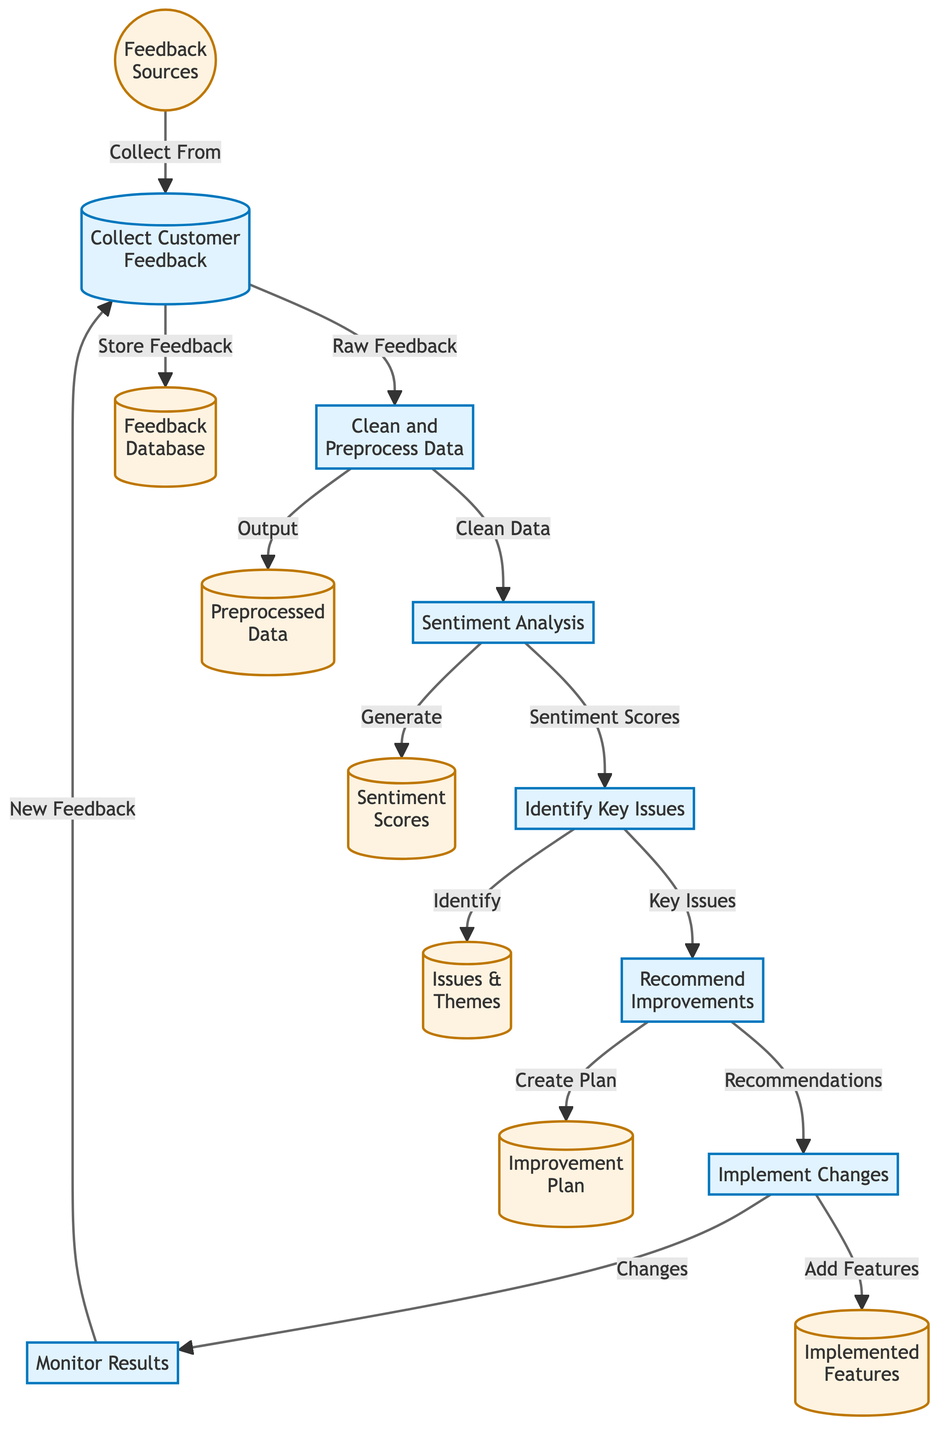What is the first step in the diagram? The first step is labeled "Collect Customer Feedback," which is the initial action that triggers the process.
Answer: Collect Customer Feedback How many processes are shown in the diagram? There are six distinct processes indicated, which are numbered from one to six in the diagram.
Answer: 6 What kind of data is collected from customer feedback? The raw feedback is collected from various feedback sources, as specified in the relationship between nodes.
Answer: Raw Feedback What follows after "Implement Changes"? After implementing changes, the next action is "Monitor Results," indicating a continuous loop of feedback evaluation.
Answer: Monitor Results Which step involves generating sentiment scores? The step called "Sentiment Analysis" is responsible for generating sentiment scores based on the cleaned data.
Answer: Sentiment Analysis What is the relationship between "Identify Key Issues" and "Recommend Improvements"? The relationship indicates that identifying key issues leads directly to recommending improvements based on those issues.
Answer: Recommendations Which node represents the output after data cleaning? The output after data cleaning is represented by the node labeled "Preprocessed Data," which indicates the result of the cleaning process.
Answer: Preprocessed Data How does the loop in the diagram begin and end? The loop begins with collecting customer feedback and ends by monitoring results, which leads back to collecting new feedback.
Answer: Collect Customer Feedback 